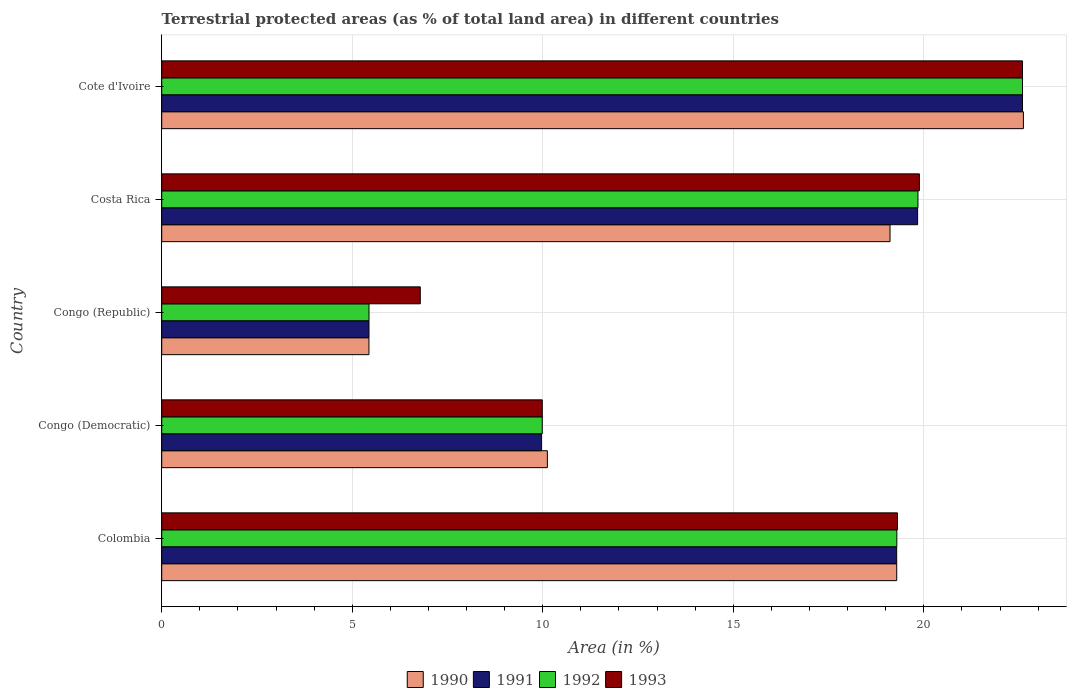How many different coloured bars are there?
Your response must be concise. 4. Are the number of bars on each tick of the Y-axis equal?
Offer a terse response. Yes. How many bars are there on the 4th tick from the bottom?
Make the answer very short. 4. What is the label of the 4th group of bars from the top?
Make the answer very short. Congo (Democratic). In how many cases, is the number of bars for a given country not equal to the number of legend labels?
Your answer should be very brief. 0. What is the percentage of terrestrial protected land in 1992 in Colombia?
Provide a succinct answer. 19.29. Across all countries, what is the maximum percentage of terrestrial protected land in 1991?
Make the answer very short. 22.59. Across all countries, what is the minimum percentage of terrestrial protected land in 1991?
Offer a terse response. 5.44. In which country was the percentage of terrestrial protected land in 1993 maximum?
Your response must be concise. Cote d'Ivoire. In which country was the percentage of terrestrial protected land in 1993 minimum?
Make the answer very short. Congo (Republic). What is the total percentage of terrestrial protected land in 1990 in the graph?
Your answer should be very brief. 76.58. What is the difference between the percentage of terrestrial protected land in 1992 in Colombia and that in Cote d'Ivoire?
Offer a very short reply. -3.3. What is the difference between the percentage of terrestrial protected land in 1990 in Congo (Republic) and the percentage of terrestrial protected land in 1992 in Costa Rica?
Keep it short and to the point. -14.41. What is the average percentage of terrestrial protected land in 1990 per country?
Provide a succinct answer. 15.32. What is the difference between the percentage of terrestrial protected land in 1991 and percentage of terrestrial protected land in 1993 in Congo (Democratic)?
Offer a terse response. -0.02. What is the ratio of the percentage of terrestrial protected land in 1992 in Colombia to that in Costa Rica?
Give a very brief answer. 0.97. What is the difference between the highest and the second highest percentage of terrestrial protected land in 1993?
Keep it short and to the point. 2.71. What is the difference between the highest and the lowest percentage of terrestrial protected land in 1990?
Your response must be concise. 17.17. In how many countries, is the percentage of terrestrial protected land in 1992 greater than the average percentage of terrestrial protected land in 1992 taken over all countries?
Your answer should be very brief. 3. Is the sum of the percentage of terrestrial protected land in 1992 in Colombia and Congo (Republic) greater than the maximum percentage of terrestrial protected land in 1990 across all countries?
Your answer should be compact. Yes. Is it the case that in every country, the sum of the percentage of terrestrial protected land in 1992 and percentage of terrestrial protected land in 1991 is greater than the sum of percentage of terrestrial protected land in 1993 and percentage of terrestrial protected land in 1990?
Provide a short and direct response. No. Is it the case that in every country, the sum of the percentage of terrestrial protected land in 1993 and percentage of terrestrial protected land in 1991 is greater than the percentage of terrestrial protected land in 1990?
Your answer should be very brief. Yes. How many bars are there?
Ensure brevity in your answer.  20. How many countries are there in the graph?
Your response must be concise. 5. What is the difference between two consecutive major ticks on the X-axis?
Offer a very short reply. 5. Are the values on the major ticks of X-axis written in scientific E-notation?
Keep it short and to the point. No. Does the graph contain any zero values?
Your answer should be compact. No. Does the graph contain grids?
Your answer should be very brief. Yes. How many legend labels are there?
Keep it short and to the point. 4. How are the legend labels stacked?
Give a very brief answer. Horizontal. What is the title of the graph?
Ensure brevity in your answer.  Terrestrial protected areas (as % of total land area) in different countries. Does "2014" appear as one of the legend labels in the graph?
Provide a succinct answer. No. What is the label or title of the X-axis?
Your response must be concise. Area (in %). What is the Area (in %) in 1990 in Colombia?
Offer a very short reply. 19.29. What is the Area (in %) of 1991 in Colombia?
Provide a short and direct response. 19.29. What is the Area (in %) of 1992 in Colombia?
Your response must be concise. 19.29. What is the Area (in %) in 1993 in Colombia?
Offer a very short reply. 19.31. What is the Area (in %) in 1990 in Congo (Democratic)?
Make the answer very short. 10.12. What is the Area (in %) of 1991 in Congo (Democratic)?
Your response must be concise. 9.96. What is the Area (in %) in 1992 in Congo (Democratic)?
Offer a terse response. 9.99. What is the Area (in %) in 1993 in Congo (Democratic)?
Your answer should be very brief. 9.99. What is the Area (in %) in 1990 in Congo (Republic)?
Offer a very short reply. 5.44. What is the Area (in %) of 1991 in Congo (Republic)?
Provide a succinct answer. 5.44. What is the Area (in %) of 1992 in Congo (Republic)?
Offer a terse response. 5.44. What is the Area (in %) of 1993 in Congo (Republic)?
Keep it short and to the point. 6.79. What is the Area (in %) in 1990 in Costa Rica?
Your answer should be compact. 19.11. What is the Area (in %) in 1991 in Costa Rica?
Offer a terse response. 19.84. What is the Area (in %) in 1992 in Costa Rica?
Provide a short and direct response. 19.85. What is the Area (in %) of 1993 in Costa Rica?
Keep it short and to the point. 19.88. What is the Area (in %) in 1990 in Cote d'Ivoire?
Give a very brief answer. 22.61. What is the Area (in %) of 1991 in Cote d'Ivoire?
Offer a very short reply. 22.59. What is the Area (in %) in 1992 in Cote d'Ivoire?
Your answer should be very brief. 22.59. What is the Area (in %) of 1993 in Cote d'Ivoire?
Offer a terse response. 22.59. Across all countries, what is the maximum Area (in %) of 1990?
Your answer should be compact. 22.61. Across all countries, what is the maximum Area (in %) of 1991?
Ensure brevity in your answer.  22.59. Across all countries, what is the maximum Area (in %) in 1992?
Offer a very short reply. 22.59. Across all countries, what is the maximum Area (in %) of 1993?
Offer a terse response. 22.59. Across all countries, what is the minimum Area (in %) in 1990?
Your answer should be compact. 5.44. Across all countries, what is the minimum Area (in %) of 1991?
Offer a very short reply. 5.44. Across all countries, what is the minimum Area (in %) in 1992?
Your answer should be compact. 5.44. Across all countries, what is the minimum Area (in %) of 1993?
Make the answer very short. 6.79. What is the total Area (in %) of 1990 in the graph?
Your answer should be very brief. 76.58. What is the total Area (in %) of 1991 in the graph?
Your response must be concise. 77.12. What is the total Area (in %) of 1992 in the graph?
Offer a terse response. 77.15. What is the total Area (in %) of 1993 in the graph?
Your answer should be compact. 78.56. What is the difference between the Area (in %) of 1990 in Colombia and that in Congo (Democratic)?
Your answer should be very brief. 9.17. What is the difference between the Area (in %) in 1991 in Colombia and that in Congo (Democratic)?
Give a very brief answer. 9.32. What is the difference between the Area (in %) in 1992 in Colombia and that in Congo (Democratic)?
Keep it short and to the point. 9.3. What is the difference between the Area (in %) of 1993 in Colombia and that in Congo (Democratic)?
Provide a short and direct response. 9.32. What is the difference between the Area (in %) of 1990 in Colombia and that in Congo (Republic)?
Your answer should be very brief. 13.85. What is the difference between the Area (in %) of 1991 in Colombia and that in Congo (Republic)?
Provide a short and direct response. 13.85. What is the difference between the Area (in %) of 1992 in Colombia and that in Congo (Republic)?
Your response must be concise. 13.85. What is the difference between the Area (in %) of 1993 in Colombia and that in Congo (Republic)?
Your answer should be very brief. 12.52. What is the difference between the Area (in %) in 1990 in Colombia and that in Costa Rica?
Your response must be concise. 0.18. What is the difference between the Area (in %) in 1991 in Colombia and that in Costa Rica?
Your answer should be very brief. -0.55. What is the difference between the Area (in %) in 1992 in Colombia and that in Costa Rica?
Provide a succinct answer. -0.55. What is the difference between the Area (in %) of 1993 in Colombia and that in Costa Rica?
Provide a short and direct response. -0.57. What is the difference between the Area (in %) in 1990 in Colombia and that in Cote d'Ivoire?
Your answer should be compact. -3.32. What is the difference between the Area (in %) in 1991 in Colombia and that in Cote d'Ivoire?
Give a very brief answer. -3.3. What is the difference between the Area (in %) in 1992 in Colombia and that in Cote d'Ivoire?
Provide a short and direct response. -3.3. What is the difference between the Area (in %) in 1993 in Colombia and that in Cote d'Ivoire?
Keep it short and to the point. -3.28. What is the difference between the Area (in %) in 1990 in Congo (Democratic) and that in Congo (Republic)?
Your answer should be very brief. 4.68. What is the difference between the Area (in %) of 1991 in Congo (Democratic) and that in Congo (Republic)?
Offer a terse response. 4.52. What is the difference between the Area (in %) in 1992 in Congo (Democratic) and that in Congo (Republic)?
Offer a very short reply. 4.55. What is the difference between the Area (in %) in 1993 in Congo (Democratic) and that in Congo (Republic)?
Provide a short and direct response. 3.2. What is the difference between the Area (in %) in 1990 in Congo (Democratic) and that in Costa Rica?
Offer a terse response. -8.99. What is the difference between the Area (in %) of 1991 in Congo (Democratic) and that in Costa Rica?
Your answer should be very brief. -9.87. What is the difference between the Area (in %) in 1992 in Congo (Democratic) and that in Costa Rica?
Your answer should be very brief. -9.86. What is the difference between the Area (in %) in 1993 in Congo (Democratic) and that in Costa Rica?
Offer a terse response. -9.9. What is the difference between the Area (in %) in 1990 in Congo (Democratic) and that in Cote d'Ivoire?
Your answer should be compact. -12.49. What is the difference between the Area (in %) of 1991 in Congo (Democratic) and that in Cote d'Ivoire?
Make the answer very short. -12.63. What is the difference between the Area (in %) in 1992 in Congo (Democratic) and that in Cote d'Ivoire?
Your response must be concise. -12.6. What is the difference between the Area (in %) in 1993 in Congo (Democratic) and that in Cote d'Ivoire?
Provide a short and direct response. -12.6. What is the difference between the Area (in %) of 1990 in Congo (Republic) and that in Costa Rica?
Provide a short and direct response. -13.67. What is the difference between the Area (in %) in 1991 in Congo (Republic) and that in Costa Rica?
Offer a very short reply. -14.4. What is the difference between the Area (in %) in 1992 in Congo (Republic) and that in Costa Rica?
Your answer should be very brief. -14.41. What is the difference between the Area (in %) of 1993 in Congo (Republic) and that in Costa Rica?
Keep it short and to the point. -13.1. What is the difference between the Area (in %) in 1990 in Congo (Republic) and that in Cote d'Ivoire?
Make the answer very short. -17.17. What is the difference between the Area (in %) of 1991 in Congo (Republic) and that in Cote d'Ivoire?
Your answer should be very brief. -17.15. What is the difference between the Area (in %) of 1992 in Congo (Republic) and that in Cote d'Ivoire?
Your answer should be compact. -17.15. What is the difference between the Area (in %) in 1993 in Congo (Republic) and that in Cote d'Ivoire?
Provide a short and direct response. -15.8. What is the difference between the Area (in %) of 1990 in Costa Rica and that in Cote d'Ivoire?
Provide a succinct answer. -3.5. What is the difference between the Area (in %) in 1991 in Costa Rica and that in Cote d'Ivoire?
Your response must be concise. -2.75. What is the difference between the Area (in %) of 1992 in Costa Rica and that in Cote d'Ivoire?
Make the answer very short. -2.74. What is the difference between the Area (in %) of 1993 in Costa Rica and that in Cote d'Ivoire?
Keep it short and to the point. -2.71. What is the difference between the Area (in %) of 1990 in Colombia and the Area (in %) of 1991 in Congo (Democratic)?
Keep it short and to the point. 9.32. What is the difference between the Area (in %) in 1990 in Colombia and the Area (in %) in 1992 in Congo (Democratic)?
Provide a short and direct response. 9.3. What is the difference between the Area (in %) in 1990 in Colombia and the Area (in %) in 1993 in Congo (Democratic)?
Your answer should be compact. 9.3. What is the difference between the Area (in %) in 1991 in Colombia and the Area (in %) in 1992 in Congo (Democratic)?
Your answer should be very brief. 9.3. What is the difference between the Area (in %) in 1991 in Colombia and the Area (in %) in 1993 in Congo (Democratic)?
Provide a succinct answer. 9.3. What is the difference between the Area (in %) of 1992 in Colombia and the Area (in %) of 1993 in Congo (Democratic)?
Make the answer very short. 9.3. What is the difference between the Area (in %) in 1990 in Colombia and the Area (in %) in 1991 in Congo (Republic)?
Offer a terse response. 13.85. What is the difference between the Area (in %) in 1990 in Colombia and the Area (in %) in 1992 in Congo (Republic)?
Make the answer very short. 13.85. What is the difference between the Area (in %) of 1990 in Colombia and the Area (in %) of 1993 in Congo (Republic)?
Offer a very short reply. 12.5. What is the difference between the Area (in %) in 1991 in Colombia and the Area (in %) in 1992 in Congo (Republic)?
Ensure brevity in your answer.  13.85. What is the difference between the Area (in %) of 1991 in Colombia and the Area (in %) of 1993 in Congo (Republic)?
Ensure brevity in your answer.  12.5. What is the difference between the Area (in %) in 1992 in Colombia and the Area (in %) in 1993 in Congo (Republic)?
Provide a short and direct response. 12.51. What is the difference between the Area (in %) of 1990 in Colombia and the Area (in %) of 1991 in Costa Rica?
Your response must be concise. -0.55. What is the difference between the Area (in %) of 1990 in Colombia and the Area (in %) of 1992 in Costa Rica?
Give a very brief answer. -0.56. What is the difference between the Area (in %) of 1990 in Colombia and the Area (in %) of 1993 in Costa Rica?
Provide a succinct answer. -0.6. What is the difference between the Area (in %) in 1991 in Colombia and the Area (in %) in 1992 in Costa Rica?
Provide a succinct answer. -0.56. What is the difference between the Area (in %) in 1991 in Colombia and the Area (in %) in 1993 in Costa Rica?
Offer a terse response. -0.6. What is the difference between the Area (in %) of 1992 in Colombia and the Area (in %) of 1993 in Costa Rica?
Your response must be concise. -0.59. What is the difference between the Area (in %) in 1990 in Colombia and the Area (in %) in 1991 in Cote d'Ivoire?
Offer a terse response. -3.3. What is the difference between the Area (in %) of 1990 in Colombia and the Area (in %) of 1992 in Cote d'Ivoire?
Give a very brief answer. -3.3. What is the difference between the Area (in %) in 1990 in Colombia and the Area (in %) in 1993 in Cote d'Ivoire?
Provide a succinct answer. -3.3. What is the difference between the Area (in %) in 1991 in Colombia and the Area (in %) in 1992 in Cote d'Ivoire?
Make the answer very short. -3.3. What is the difference between the Area (in %) in 1991 in Colombia and the Area (in %) in 1993 in Cote d'Ivoire?
Your answer should be very brief. -3.3. What is the difference between the Area (in %) of 1992 in Colombia and the Area (in %) of 1993 in Cote d'Ivoire?
Provide a short and direct response. -3.3. What is the difference between the Area (in %) in 1990 in Congo (Democratic) and the Area (in %) in 1991 in Congo (Republic)?
Offer a very short reply. 4.68. What is the difference between the Area (in %) in 1990 in Congo (Democratic) and the Area (in %) in 1992 in Congo (Republic)?
Keep it short and to the point. 4.68. What is the difference between the Area (in %) of 1990 in Congo (Democratic) and the Area (in %) of 1993 in Congo (Republic)?
Your response must be concise. 3.34. What is the difference between the Area (in %) of 1991 in Congo (Democratic) and the Area (in %) of 1992 in Congo (Republic)?
Offer a terse response. 4.52. What is the difference between the Area (in %) in 1991 in Congo (Democratic) and the Area (in %) in 1993 in Congo (Republic)?
Offer a terse response. 3.18. What is the difference between the Area (in %) in 1992 in Congo (Democratic) and the Area (in %) in 1993 in Congo (Republic)?
Your answer should be compact. 3.2. What is the difference between the Area (in %) in 1990 in Congo (Democratic) and the Area (in %) in 1991 in Costa Rica?
Provide a short and direct response. -9.72. What is the difference between the Area (in %) of 1990 in Congo (Democratic) and the Area (in %) of 1992 in Costa Rica?
Keep it short and to the point. -9.73. What is the difference between the Area (in %) of 1990 in Congo (Democratic) and the Area (in %) of 1993 in Costa Rica?
Provide a succinct answer. -9.76. What is the difference between the Area (in %) in 1991 in Congo (Democratic) and the Area (in %) in 1992 in Costa Rica?
Offer a terse response. -9.88. What is the difference between the Area (in %) in 1991 in Congo (Democratic) and the Area (in %) in 1993 in Costa Rica?
Offer a very short reply. -9.92. What is the difference between the Area (in %) in 1992 in Congo (Democratic) and the Area (in %) in 1993 in Costa Rica?
Provide a succinct answer. -9.9. What is the difference between the Area (in %) in 1990 in Congo (Democratic) and the Area (in %) in 1991 in Cote d'Ivoire?
Ensure brevity in your answer.  -12.47. What is the difference between the Area (in %) of 1990 in Congo (Democratic) and the Area (in %) of 1992 in Cote d'Ivoire?
Offer a very short reply. -12.47. What is the difference between the Area (in %) in 1990 in Congo (Democratic) and the Area (in %) in 1993 in Cote d'Ivoire?
Provide a succinct answer. -12.47. What is the difference between the Area (in %) in 1991 in Congo (Democratic) and the Area (in %) in 1992 in Cote d'Ivoire?
Give a very brief answer. -12.63. What is the difference between the Area (in %) in 1991 in Congo (Democratic) and the Area (in %) in 1993 in Cote d'Ivoire?
Your answer should be compact. -12.63. What is the difference between the Area (in %) in 1992 in Congo (Democratic) and the Area (in %) in 1993 in Cote d'Ivoire?
Make the answer very short. -12.6. What is the difference between the Area (in %) in 1990 in Congo (Republic) and the Area (in %) in 1991 in Costa Rica?
Give a very brief answer. -14.4. What is the difference between the Area (in %) of 1990 in Congo (Republic) and the Area (in %) of 1992 in Costa Rica?
Make the answer very short. -14.41. What is the difference between the Area (in %) in 1990 in Congo (Republic) and the Area (in %) in 1993 in Costa Rica?
Ensure brevity in your answer.  -14.45. What is the difference between the Area (in %) of 1991 in Congo (Republic) and the Area (in %) of 1992 in Costa Rica?
Your answer should be very brief. -14.41. What is the difference between the Area (in %) of 1991 in Congo (Republic) and the Area (in %) of 1993 in Costa Rica?
Provide a succinct answer. -14.44. What is the difference between the Area (in %) of 1992 in Congo (Republic) and the Area (in %) of 1993 in Costa Rica?
Your answer should be very brief. -14.44. What is the difference between the Area (in %) of 1990 in Congo (Republic) and the Area (in %) of 1991 in Cote d'Ivoire?
Your answer should be compact. -17.15. What is the difference between the Area (in %) in 1990 in Congo (Republic) and the Area (in %) in 1992 in Cote d'Ivoire?
Keep it short and to the point. -17.15. What is the difference between the Area (in %) of 1990 in Congo (Republic) and the Area (in %) of 1993 in Cote d'Ivoire?
Provide a short and direct response. -17.15. What is the difference between the Area (in %) in 1991 in Congo (Republic) and the Area (in %) in 1992 in Cote d'Ivoire?
Keep it short and to the point. -17.15. What is the difference between the Area (in %) in 1991 in Congo (Republic) and the Area (in %) in 1993 in Cote d'Ivoire?
Provide a short and direct response. -17.15. What is the difference between the Area (in %) in 1992 in Congo (Republic) and the Area (in %) in 1993 in Cote d'Ivoire?
Offer a very short reply. -17.15. What is the difference between the Area (in %) in 1990 in Costa Rica and the Area (in %) in 1991 in Cote d'Ivoire?
Provide a short and direct response. -3.48. What is the difference between the Area (in %) in 1990 in Costa Rica and the Area (in %) in 1992 in Cote d'Ivoire?
Offer a very short reply. -3.48. What is the difference between the Area (in %) of 1990 in Costa Rica and the Area (in %) of 1993 in Cote d'Ivoire?
Provide a short and direct response. -3.48. What is the difference between the Area (in %) in 1991 in Costa Rica and the Area (in %) in 1992 in Cote d'Ivoire?
Offer a terse response. -2.75. What is the difference between the Area (in %) of 1991 in Costa Rica and the Area (in %) of 1993 in Cote d'Ivoire?
Your response must be concise. -2.75. What is the difference between the Area (in %) in 1992 in Costa Rica and the Area (in %) in 1993 in Cote d'Ivoire?
Ensure brevity in your answer.  -2.74. What is the average Area (in %) of 1990 per country?
Your response must be concise. 15.32. What is the average Area (in %) of 1991 per country?
Your answer should be compact. 15.42. What is the average Area (in %) of 1992 per country?
Ensure brevity in your answer.  15.43. What is the average Area (in %) in 1993 per country?
Give a very brief answer. 15.71. What is the difference between the Area (in %) of 1990 and Area (in %) of 1991 in Colombia?
Offer a very short reply. 0. What is the difference between the Area (in %) in 1990 and Area (in %) in 1992 in Colombia?
Your answer should be compact. -0. What is the difference between the Area (in %) of 1990 and Area (in %) of 1993 in Colombia?
Provide a short and direct response. -0.02. What is the difference between the Area (in %) of 1991 and Area (in %) of 1992 in Colombia?
Provide a succinct answer. -0. What is the difference between the Area (in %) of 1991 and Area (in %) of 1993 in Colombia?
Offer a terse response. -0.02. What is the difference between the Area (in %) of 1992 and Area (in %) of 1993 in Colombia?
Your answer should be compact. -0.02. What is the difference between the Area (in %) in 1990 and Area (in %) in 1991 in Congo (Democratic)?
Your response must be concise. 0.16. What is the difference between the Area (in %) of 1990 and Area (in %) of 1992 in Congo (Democratic)?
Provide a short and direct response. 0.13. What is the difference between the Area (in %) of 1990 and Area (in %) of 1993 in Congo (Democratic)?
Your answer should be very brief. 0.13. What is the difference between the Area (in %) in 1991 and Area (in %) in 1992 in Congo (Democratic)?
Keep it short and to the point. -0.02. What is the difference between the Area (in %) in 1991 and Area (in %) in 1993 in Congo (Democratic)?
Keep it short and to the point. -0.02. What is the difference between the Area (in %) of 1992 and Area (in %) of 1993 in Congo (Democratic)?
Provide a succinct answer. -0. What is the difference between the Area (in %) in 1990 and Area (in %) in 1991 in Congo (Republic)?
Ensure brevity in your answer.  -0. What is the difference between the Area (in %) of 1990 and Area (in %) of 1992 in Congo (Republic)?
Provide a short and direct response. -0. What is the difference between the Area (in %) in 1990 and Area (in %) in 1993 in Congo (Republic)?
Your answer should be very brief. -1.35. What is the difference between the Area (in %) in 1991 and Area (in %) in 1992 in Congo (Republic)?
Give a very brief answer. 0. What is the difference between the Area (in %) in 1991 and Area (in %) in 1993 in Congo (Republic)?
Ensure brevity in your answer.  -1.35. What is the difference between the Area (in %) of 1992 and Area (in %) of 1993 in Congo (Republic)?
Offer a very short reply. -1.35. What is the difference between the Area (in %) in 1990 and Area (in %) in 1991 in Costa Rica?
Your answer should be very brief. -0.72. What is the difference between the Area (in %) of 1990 and Area (in %) of 1992 in Costa Rica?
Make the answer very short. -0.73. What is the difference between the Area (in %) in 1990 and Area (in %) in 1993 in Costa Rica?
Your answer should be very brief. -0.77. What is the difference between the Area (in %) of 1991 and Area (in %) of 1992 in Costa Rica?
Provide a short and direct response. -0.01. What is the difference between the Area (in %) of 1991 and Area (in %) of 1993 in Costa Rica?
Ensure brevity in your answer.  -0.05. What is the difference between the Area (in %) of 1992 and Area (in %) of 1993 in Costa Rica?
Your answer should be compact. -0.04. What is the difference between the Area (in %) in 1990 and Area (in %) in 1991 in Cote d'Ivoire?
Keep it short and to the point. 0.02. What is the difference between the Area (in %) of 1990 and Area (in %) of 1992 in Cote d'Ivoire?
Provide a short and direct response. 0.02. What is the difference between the Area (in %) in 1990 and Area (in %) in 1993 in Cote d'Ivoire?
Your answer should be very brief. 0.02. What is the difference between the Area (in %) of 1991 and Area (in %) of 1993 in Cote d'Ivoire?
Your response must be concise. 0. What is the ratio of the Area (in %) of 1990 in Colombia to that in Congo (Democratic)?
Keep it short and to the point. 1.91. What is the ratio of the Area (in %) of 1991 in Colombia to that in Congo (Democratic)?
Your response must be concise. 1.94. What is the ratio of the Area (in %) in 1992 in Colombia to that in Congo (Democratic)?
Your answer should be very brief. 1.93. What is the ratio of the Area (in %) of 1993 in Colombia to that in Congo (Democratic)?
Offer a very short reply. 1.93. What is the ratio of the Area (in %) in 1990 in Colombia to that in Congo (Republic)?
Ensure brevity in your answer.  3.55. What is the ratio of the Area (in %) in 1991 in Colombia to that in Congo (Republic)?
Provide a short and direct response. 3.55. What is the ratio of the Area (in %) of 1992 in Colombia to that in Congo (Republic)?
Provide a succinct answer. 3.55. What is the ratio of the Area (in %) in 1993 in Colombia to that in Congo (Republic)?
Make the answer very short. 2.85. What is the ratio of the Area (in %) of 1990 in Colombia to that in Costa Rica?
Keep it short and to the point. 1.01. What is the ratio of the Area (in %) in 1991 in Colombia to that in Costa Rica?
Your answer should be compact. 0.97. What is the ratio of the Area (in %) in 1992 in Colombia to that in Costa Rica?
Provide a succinct answer. 0.97. What is the ratio of the Area (in %) of 1993 in Colombia to that in Costa Rica?
Offer a very short reply. 0.97. What is the ratio of the Area (in %) of 1990 in Colombia to that in Cote d'Ivoire?
Your answer should be compact. 0.85. What is the ratio of the Area (in %) of 1991 in Colombia to that in Cote d'Ivoire?
Your response must be concise. 0.85. What is the ratio of the Area (in %) of 1992 in Colombia to that in Cote d'Ivoire?
Your response must be concise. 0.85. What is the ratio of the Area (in %) of 1993 in Colombia to that in Cote d'Ivoire?
Give a very brief answer. 0.85. What is the ratio of the Area (in %) of 1990 in Congo (Democratic) to that in Congo (Republic)?
Offer a terse response. 1.86. What is the ratio of the Area (in %) of 1991 in Congo (Democratic) to that in Congo (Republic)?
Make the answer very short. 1.83. What is the ratio of the Area (in %) in 1992 in Congo (Democratic) to that in Congo (Republic)?
Offer a terse response. 1.84. What is the ratio of the Area (in %) of 1993 in Congo (Democratic) to that in Congo (Republic)?
Make the answer very short. 1.47. What is the ratio of the Area (in %) in 1990 in Congo (Democratic) to that in Costa Rica?
Your response must be concise. 0.53. What is the ratio of the Area (in %) of 1991 in Congo (Democratic) to that in Costa Rica?
Provide a succinct answer. 0.5. What is the ratio of the Area (in %) in 1992 in Congo (Democratic) to that in Costa Rica?
Ensure brevity in your answer.  0.5. What is the ratio of the Area (in %) of 1993 in Congo (Democratic) to that in Costa Rica?
Your response must be concise. 0.5. What is the ratio of the Area (in %) in 1990 in Congo (Democratic) to that in Cote d'Ivoire?
Offer a very short reply. 0.45. What is the ratio of the Area (in %) of 1991 in Congo (Democratic) to that in Cote d'Ivoire?
Offer a terse response. 0.44. What is the ratio of the Area (in %) in 1992 in Congo (Democratic) to that in Cote d'Ivoire?
Your response must be concise. 0.44. What is the ratio of the Area (in %) in 1993 in Congo (Democratic) to that in Cote d'Ivoire?
Keep it short and to the point. 0.44. What is the ratio of the Area (in %) in 1990 in Congo (Republic) to that in Costa Rica?
Offer a very short reply. 0.28. What is the ratio of the Area (in %) of 1991 in Congo (Republic) to that in Costa Rica?
Keep it short and to the point. 0.27. What is the ratio of the Area (in %) of 1992 in Congo (Republic) to that in Costa Rica?
Ensure brevity in your answer.  0.27. What is the ratio of the Area (in %) in 1993 in Congo (Republic) to that in Costa Rica?
Keep it short and to the point. 0.34. What is the ratio of the Area (in %) in 1990 in Congo (Republic) to that in Cote d'Ivoire?
Provide a succinct answer. 0.24. What is the ratio of the Area (in %) in 1991 in Congo (Republic) to that in Cote d'Ivoire?
Ensure brevity in your answer.  0.24. What is the ratio of the Area (in %) in 1992 in Congo (Republic) to that in Cote d'Ivoire?
Provide a short and direct response. 0.24. What is the ratio of the Area (in %) of 1993 in Congo (Republic) to that in Cote d'Ivoire?
Give a very brief answer. 0.3. What is the ratio of the Area (in %) of 1990 in Costa Rica to that in Cote d'Ivoire?
Provide a short and direct response. 0.85. What is the ratio of the Area (in %) in 1991 in Costa Rica to that in Cote d'Ivoire?
Ensure brevity in your answer.  0.88. What is the ratio of the Area (in %) in 1992 in Costa Rica to that in Cote d'Ivoire?
Provide a succinct answer. 0.88. What is the ratio of the Area (in %) in 1993 in Costa Rica to that in Cote d'Ivoire?
Provide a short and direct response. 0.88. What is the difference between the highest and the second highest Area (in %) in 1990?
Provide a short and direct response. 3.32. What is the difference between the highest and the second highest Area (in %) of 1991?
Offer a terse response. 2.75. What is the difference between the highest and the second highest Area (in %) in 1992?
Your response must be concise. 2.74. What is the difference between the highest and the second highest Area (in %) of 1993?
Offer a very short reply. 2.71. What is the difference between the highest and the lowest Area (in %) of 1990?
Offer a terse response. 17.17. What is the difference between the highest and the lowest Area (in %) in 1991?
Ensure brevity in your answer.  17.15. What is the difference between the highest and the lowest Area (in %) of 1992?
Provide a succinct answer. 17.15. What is the difference between the highest and the lowest Area (in %) in 1993?
Your answer should be very brief. 15.8. 